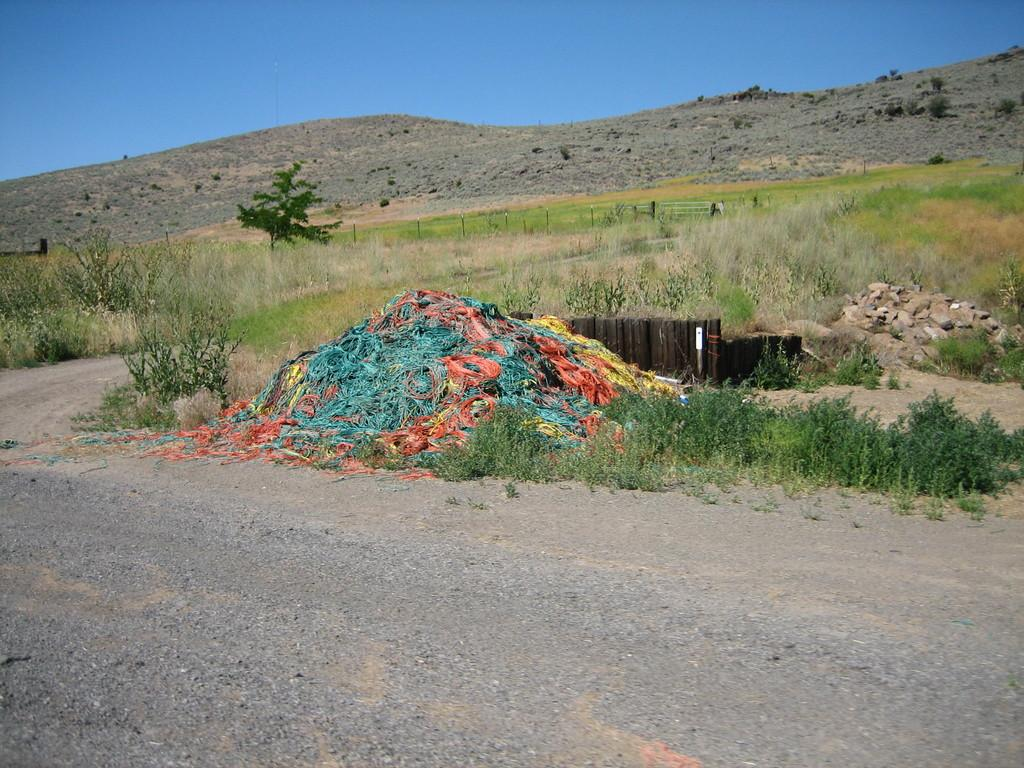What can be seen in the foreground of the image? In the foreground of the image, there is a road, grass, plants, stones, and colored wires. What is visible in the background of the image? In the background of the image, there is grassland, hills, and the sky. Can you describe the terrain in the foreground of the image? The terrain in the foreground of the image includes grass, plants, stones, and colored wires. What type of natural features can be seen in the background of the image? In the background of the image, there are hills and the sky. What type of music can be heard playing in the background of the image? There is no music present in the image, as it is a still photograph. How many stars can be seen in the image? There are no stars visible in the image, as it is a landscape scene with hills and grassland in the background. 